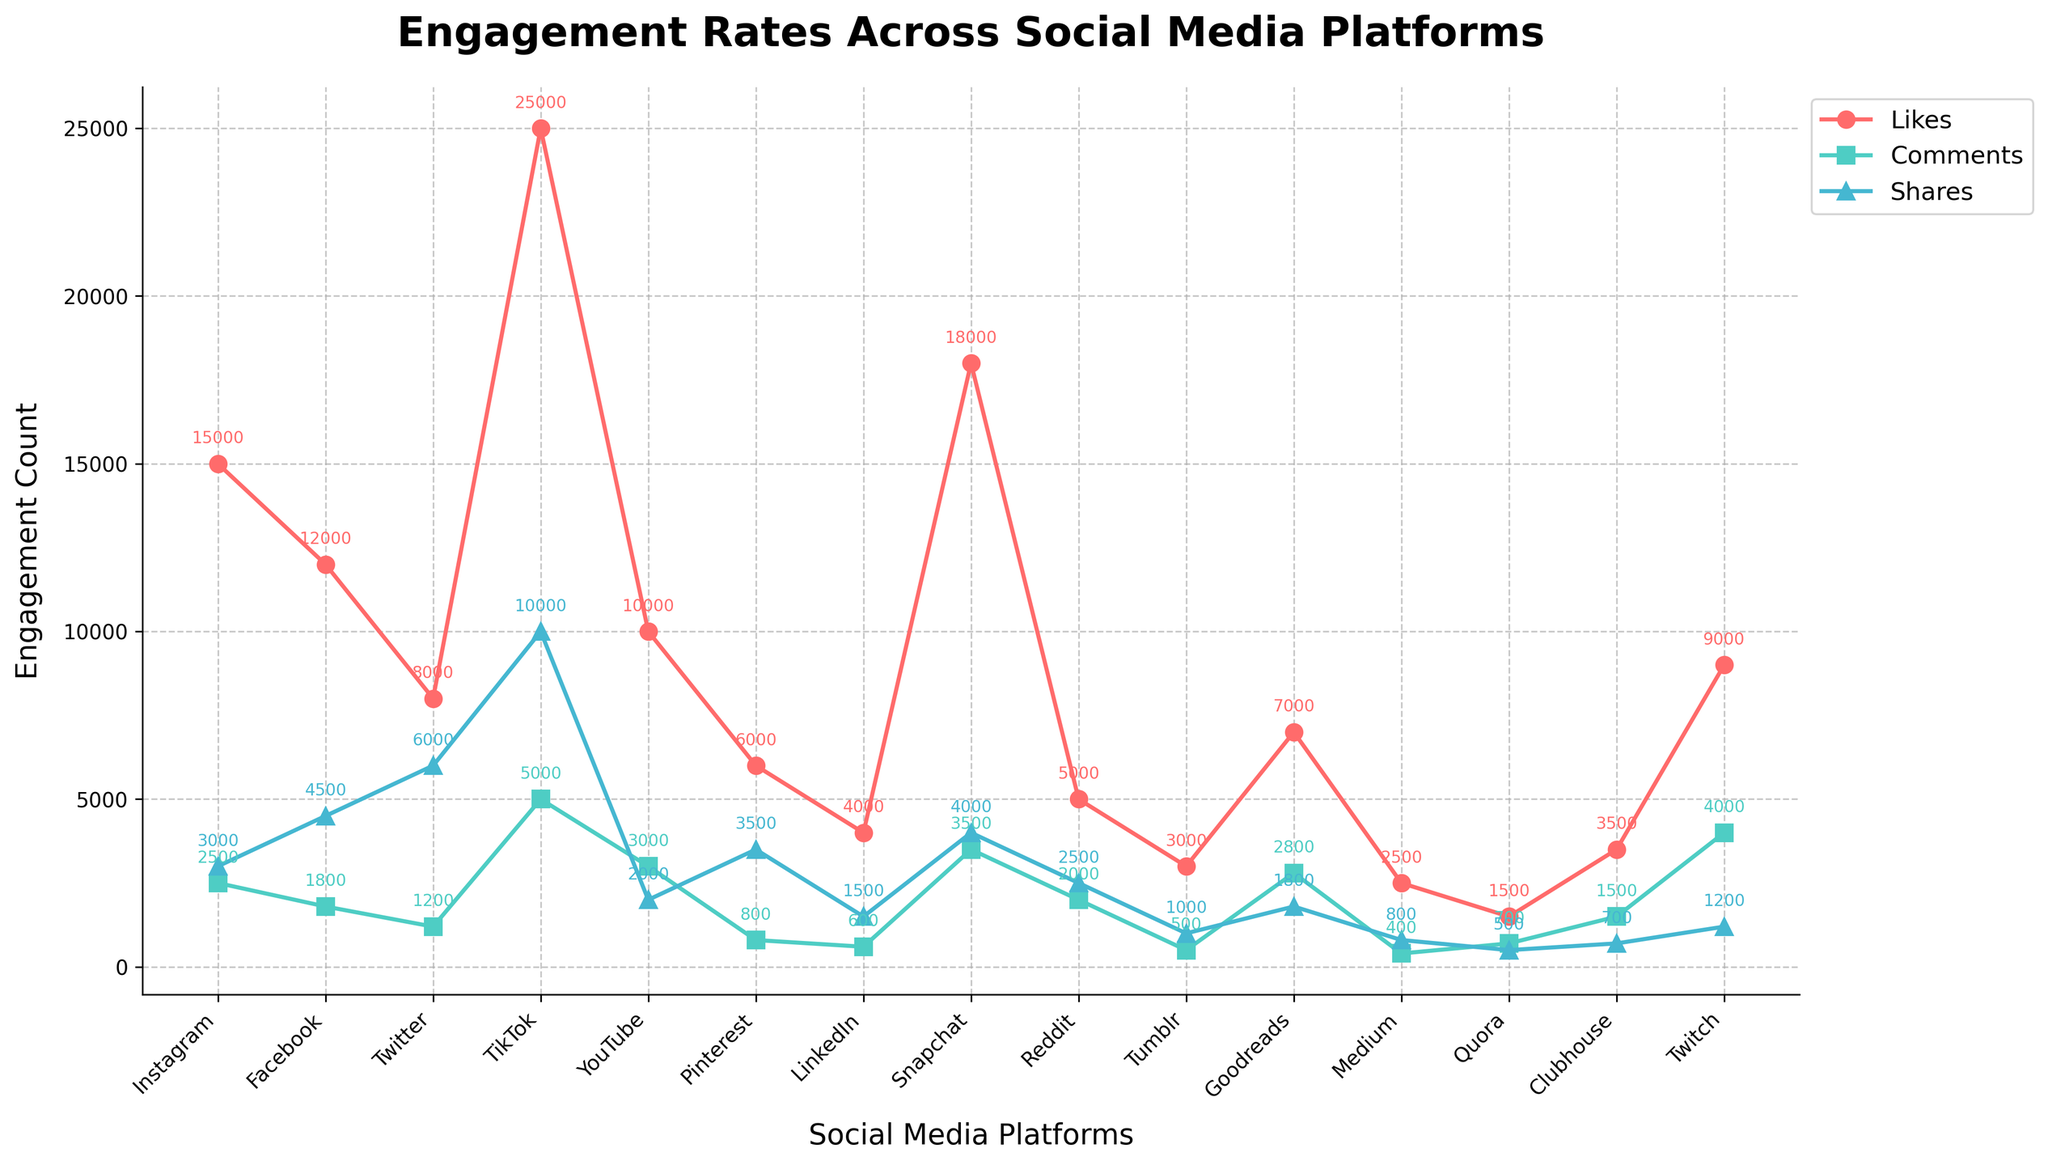Which platform has the highest number of likes? The platform with the highest data point on the 'Likes' line would indicate the highest number of likes.
Answer: TikTok Which two platforms have the closest number of comments? To find the closest number of comments, look at the 'Comments' line for the two points that are closest in value.
Answer: Instagram and TikTok What is the total number of likes, comments, and shares on TikTok? Sum the 'Likes,' 'Comments,' and 'Shares' values for TikTok. 25000 + 5000 + 10000 = 40000.
Answer: 40000 On which platform are shares greater than or equal to comments? Look for instances where the 'Shares' line is at the same level or higher than the 'Comments' line. Check specific data points for verification.
Answer: Facebook, Twitter, Pinterest, Snapchat, Reddit Which platform has the lowest engagement rate (sum of likes, comments, and shares)? Calculate the total engagement rate by summing 'Likes,' 'Comments,' and 'Shares' for each platform, then find the minimum. Medium has 2500 + 400 + 800 = 3700, which is the lowest.
Answer: Medium What’s the difference in the number of shares between Instagram and Facebook? Subtract Facebook shares from Instagram shares: 4500 (Facebook) - 3000 (Instagram) = 1500.
Answer: -1500 Compare the trends of 'Likes' and 'Shares.' Which metric shows more variation across platforms? Find the difference between the highest and lowest values for 'Likes' and 'Shares' respectively. The metric with the larger range shows more variation. 'Likes' have a range from 2500 (Medium) to 25000 (TikTok). 'Shares' have a range from 500 (Quora) to 10000 (TikTok).
Answer: Likes Which platform has more comments than likes? Compare the 'Comments' and 'Likes' lines to find the platforms where the 'Comments' line is higher.
Answer: None What's the average number of comments received on YouTube and Reddit posts? Sum the comments for YouTube and Reddit and then divide by 2. (3000 + 2000)/2 = 2500.
Answer: 2500 Which platforms have more than 8000 likes? Identify all platforms where the 'Likes' data point is above 8000.
Answer: Instagram, TikTok, Snapchat, YouTube, Twitch 